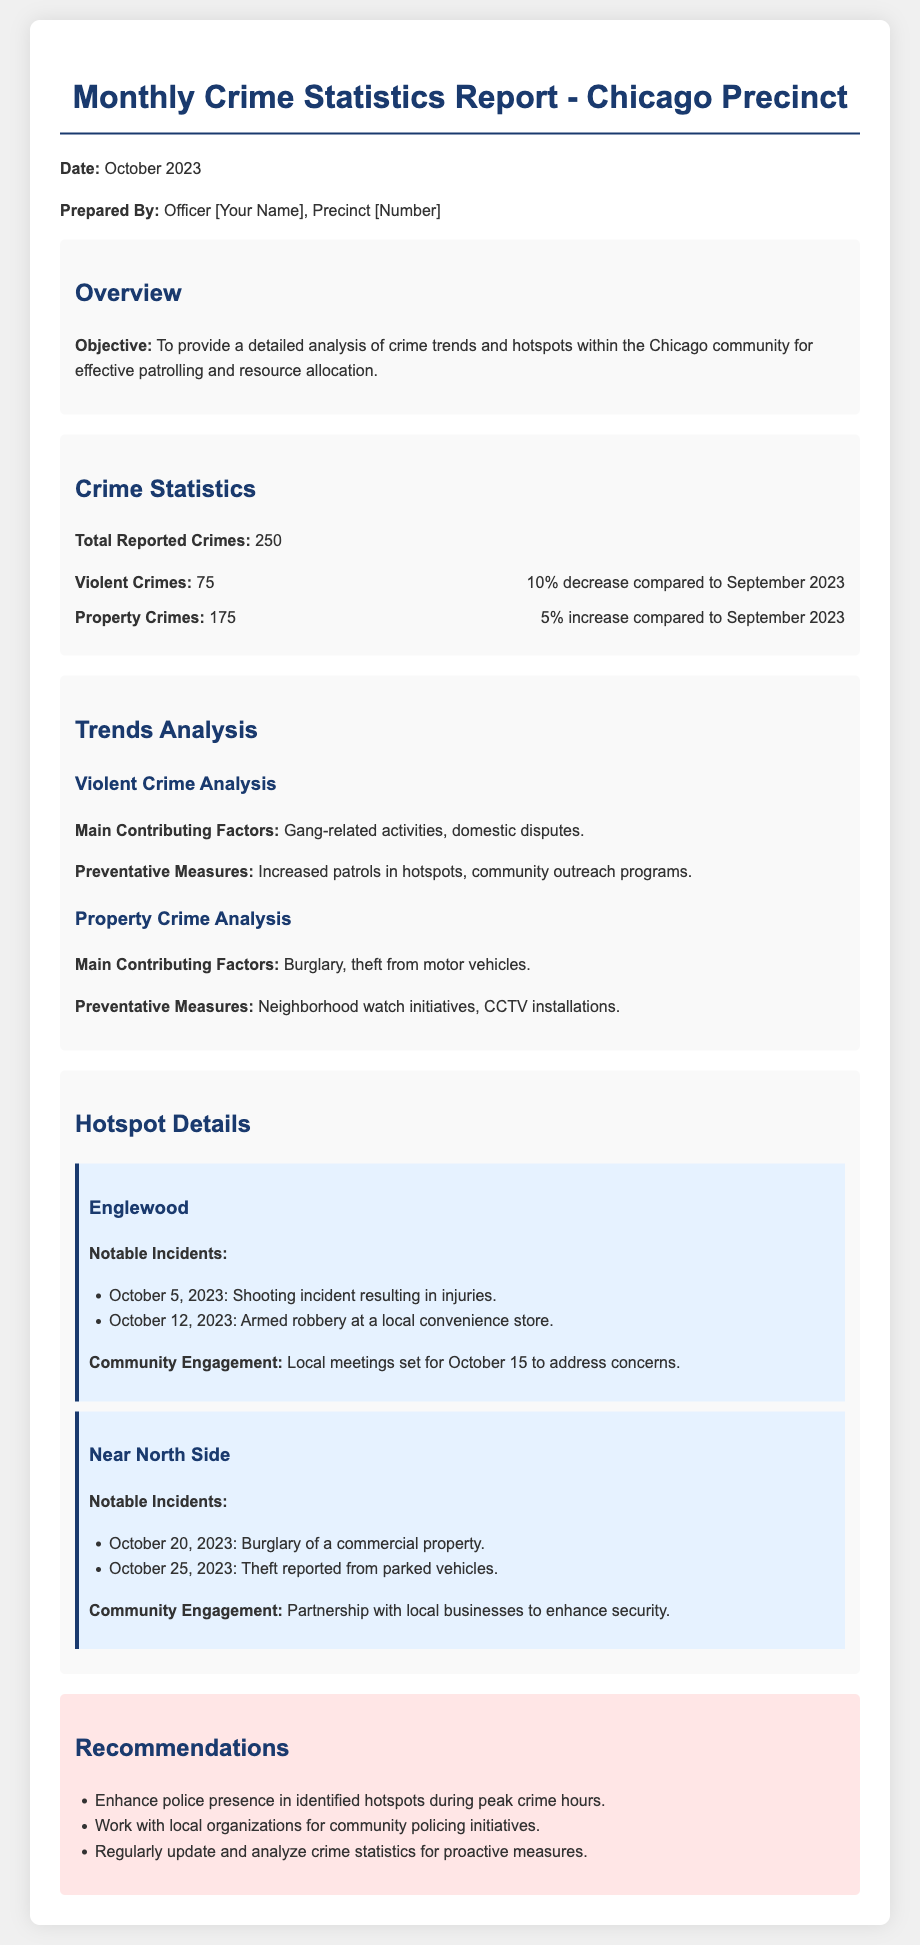What is the total reported crimes? The total reported crimes is stated as 250 in the document.
Answer: 250 What percentage decrease was observed in violent crimes? The document states a 10% decrease compared to September 2023 for violent crimes.
Answer: 10% What is the main contributing factor to property crime? The document lists burglary and theft from motor vehicles as the main contributing factors to property crime.
Answer: Burglary, theft from motor vehicles What notable incident occurred on October 5, 2023? The document mentions a shooting incident resulting in injuries as a notable incident on that date.
Answer: Shooting incident resulting in injuries What community engagement is planned for Englewood? The document states that local meetings are set for October 15 to address concerns in Englewood.
Answer: Local meetings on October 15 What does the report recommend to enhance police presence? The recommendations section states to enhance police presence in identified hotspots during peak crime hours.
Answer: Enhance police presence during peak crime hours What is the total number of violent crimes reported? The document indicates that 75 violent crimes were reported.
Answer: 75 Which area had a burglary of a commercial property? The document identifies Near North Side as the area where a burglary of a commercial property occurred.
Answer: Near North Side What is a preventative measure for violent crimes mentioned in the report? The document states that increased patrols in hotspots is a preventative measure for violent crimes.
Answer: Increased patrols in hotspots 